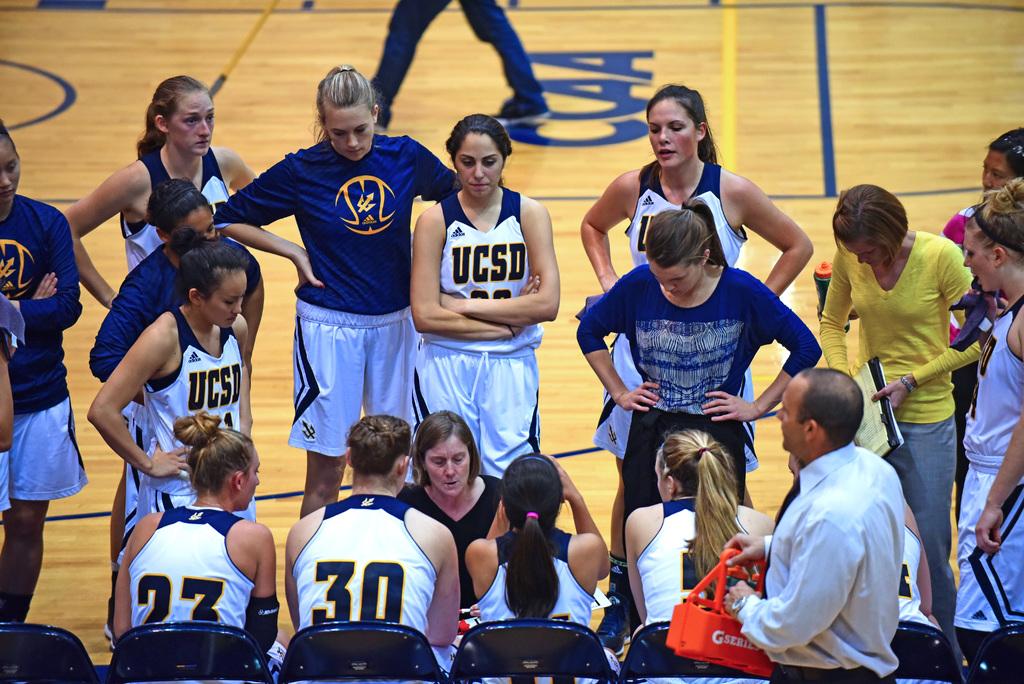What team do these players belong to?
Provide a short and direct response. Ucsd. What number is the player on the left with their back to you?
Your answer should be very brief. 23. 